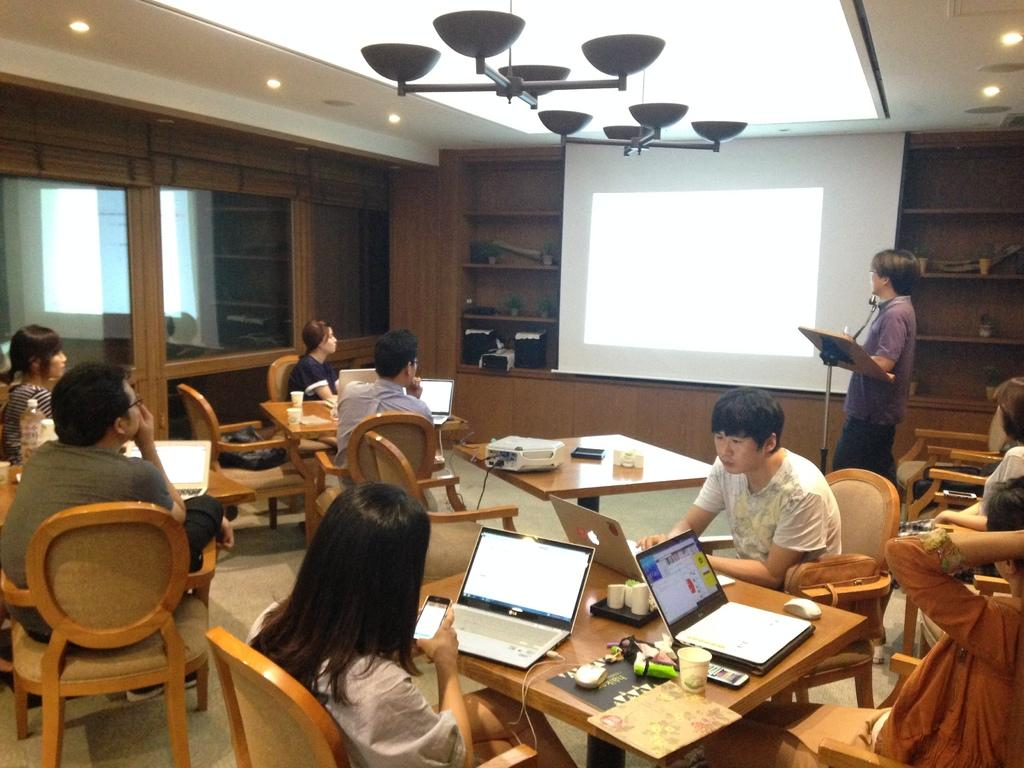What type of space is depicted in the image? There is a room in the image. What are the people in the room doing? The people are sitting on chairs in the room. Where are the people sitting in relation to the tables? The people are sitting in front of tables. What can be found on the tables in the image? There are things on the tables. Can you tell me how many cows are visible in the image? There are no cows present in the image; it features a room with people sitting in front of tables. What type of drink is being served in eggnog cups in the image? There is no mention of eggnog or any specific drink in the image; it only shows people sitting in front of tables with unspecified objects on them. 